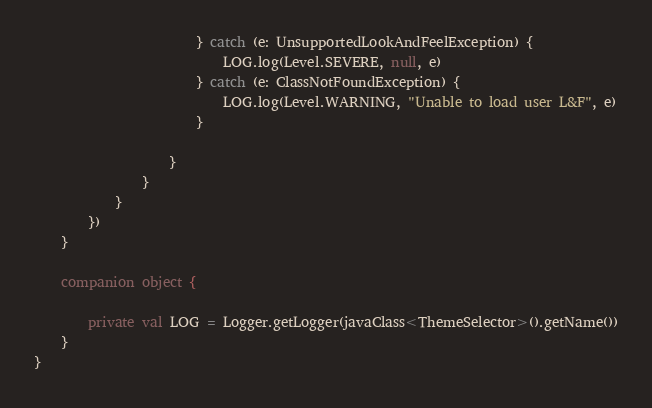Convert code to text. <code><loc_0><loc_0><loc_500><loc_500><_Kotlin_>                        } catch (e: UnsupportedLookAndFeelException) {
                            LOG.log(Level.SEVERE, null, e)
                        } catch (e: ClassNotFoundException) {
                            LOG.log(Level.WARNING, "Unable to load user L&F", e)
                        }

                    }
                }
            }
        })
    }

    companion object {

        private val LOG = Logger.getLogger(javaClass<ThemeSelector>().getName())
    }
}
</code> 